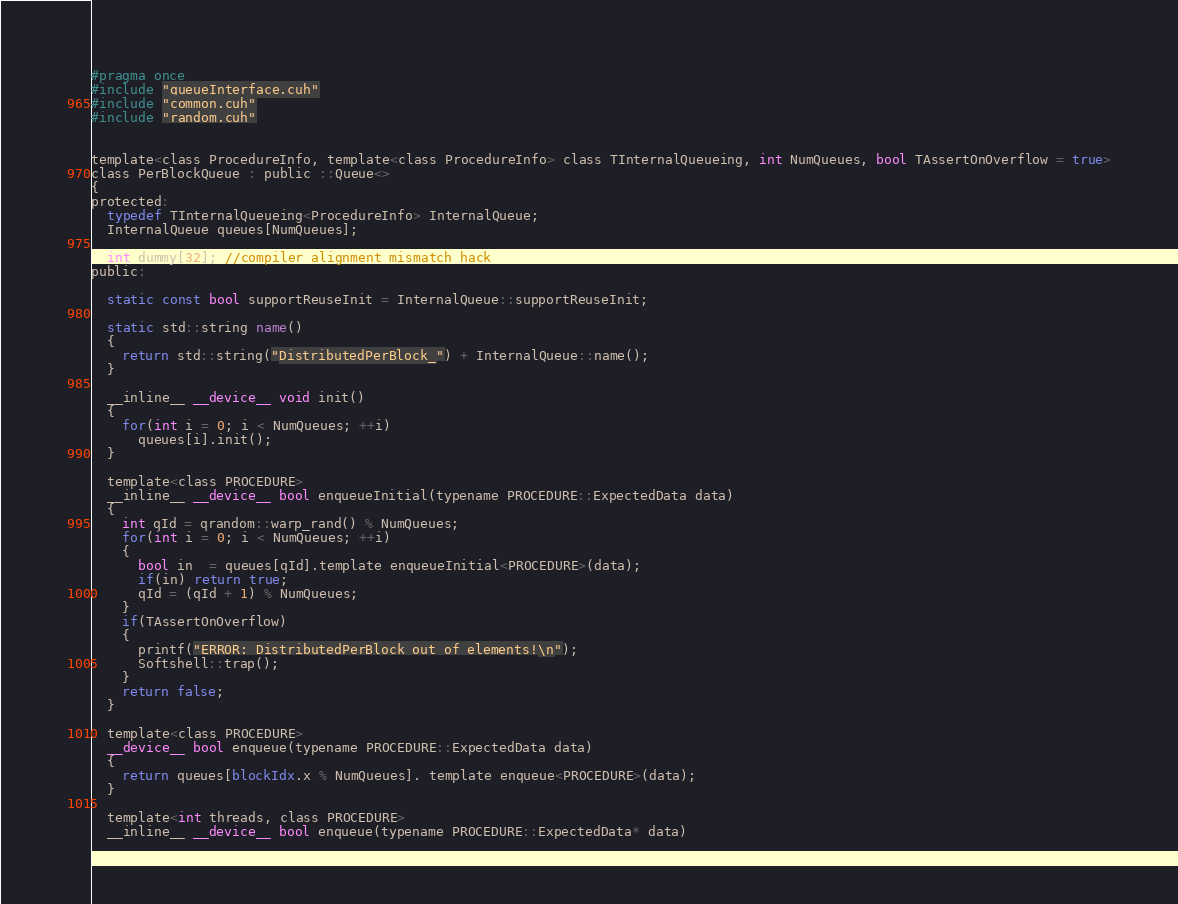<code> <loc_0><loc_0><loc_500><loc_500><_Cuda_>#pragma once
#include "queueInterface.cuh"
#include "common.cuh"
#include "random.cuh"


template<class ProcedureInfo, template<class ProcedureInfo> class TInternalQueueing, int NumQueues, bool TAssertOnOverflow = true>
class PerBlockQueue : public ::Queue<> 
{
protected:
  typedef TInternalQueueing<ProcedureInfo> InternalQueue;
  InternalQueue queues[NumQueues];

  int dummy[32]; //compiler alignment mismatch hack
public:

  static const bool supportReuseInit = InternalQueue::supportReuseInit;

  static std::string name()
  {
    return std::string("DistributedPerBlock_") + InternalQueue::name();
  }

  __inline__ __device__ void init() 
  {
    for(int i = 0; i < NumQueues; ++i)
      queues[i].init();
  }

  template<class PROCEDURE>
  __inline__ __device__ bool enqueueInitial(typename PROCEDURE::ExpectedData data) 
  {
    int qId = qrandom::warp_rand() % NumQueues;
    for(int i = 0; i < NumQueues; ++i)
    {
      bool in  = queues[qId].template enqueueInitial<PROCEDURE>(data);
      if(in) return true;
      qId = (qId + 1) % NumQueues;
    }
    if(TAssertOnOverflow)
    {
      printf("ERROR: DistributedPerBlock out of elements!\n");
      Softshell::trap();
    }
    return false;
  }

  template<class PROCEDURE>
  __device__ bool enqueue(typename PROCEDURE::ExpectedData data) 
  {        
    return queues[blockIdx.x % NumQueues]. template enqueue<PROCEDURE>(data);
  }

  template<int threads, class PROCEDURE>
  __inline__ __device__ bool enqueue(typename PROCEDURE::ExpectedData* data) </code> 